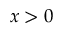<formula> <loc_0><loc_0><loc_500><loc_500>x > 0</formula> 